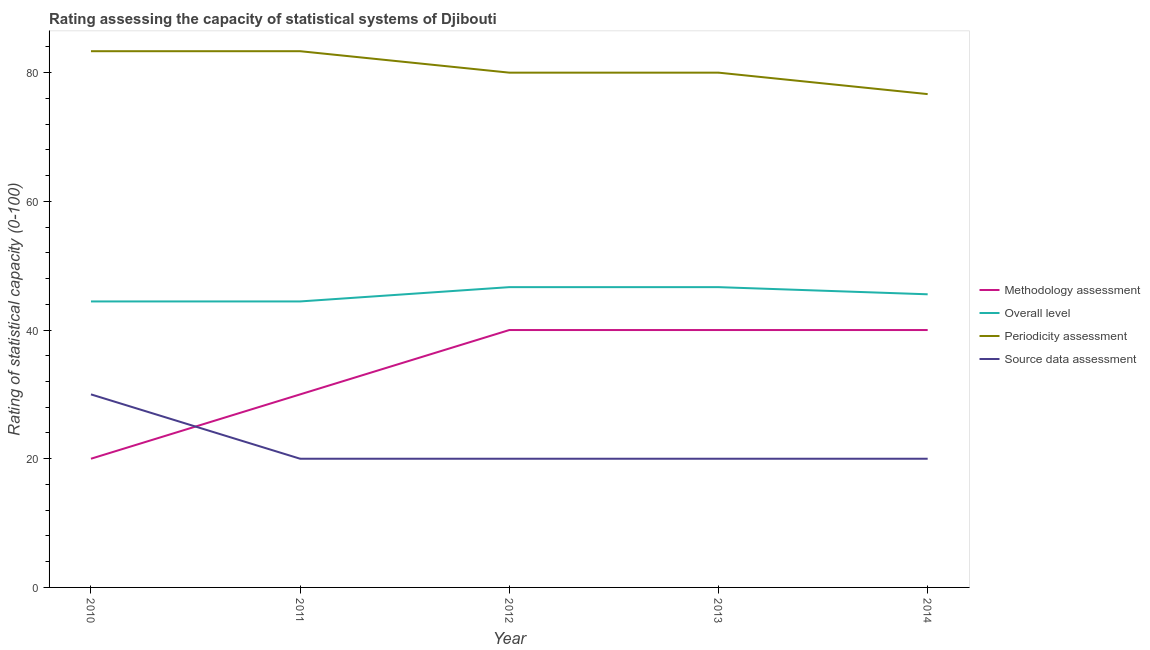How many different coloured lines are there?
Your answer should be very brief. 4. Does the line corresponding to periodicity assessment rating intersect with the line corresponding to overall level rating?
Provide a short and direct response. No. Is the number of lines equal to the number of legend labels?
Offer a very short reply. Yes. What is the periodicity assessment rating in 2011?
Offer a terse response. 83.33. Across all years, what is the maximum source data assessment rating?
Your answer should be very brief. 30. Across all years, what is the minimum periodicity assessment rating?
Offer a very short reply. 76.67. In which year was the periodicity assessment rating maximum?
Ensure brevity in your answer.  2010. In which year was the source data assessment rating minimum?
Give a very brief answer. 2011. What is the total overall level rating in the graph?
Your answer should be very brief. 227.78. What is the difference between the overall level rating in 2010 and that in 2013?
Make the answer very short. -2.22. What is the difference between the overall level rating in 2012 and the methodology assessment rating in 2010?
Provide a succinct answer. 26.67. What is the average periodicity assessment rating per year?
Ensure brevity in your answer.  80.67. In the year 2010, what is the difference between the periodicity assessment rating and methodology assessment rating?
Keep it short and to the point. 63.33. In how many years, is the source data assessment rating greater than 36?
Provide a succinct answer. 0. What is the ratio of the source data assessment rating in 2013 to that in 2014?
Keep it short and to the point. 1. Is the source data assessment rating in 2010 less than that in 2012?
Your response must be concise. No. Is the difference between the periodicity assessment rating in 2011 and 2012 greater than the difference between the overall level rating in 2011 and 2012?
Your answer should be very brief. Yes. What is the difference between the highest and the lowest periodicity assessment rating?
Provide a short and direct response. 6.67. Is the sum of the methodology assessment rating in 2010 and 2012 greater than the maximum overall level rating across all years?
Offer a terse response. Yes. Is the periodicity assessment rating strictly greater than the overall level rating over the years?
Make the answer very short. Yes. How many lines are there?
Offer a terse response. 4. How many years are there in the graph?
Offer a very short reply. 5. What is the difference between two consecutive major ticks on the Y-axis?
Keep it short and to the point. 20. Does the graph contain any zero values?
Give a very brief answer. No. Does the graph contain grids?
Your answer should be very brief. No. Where does the legend appear in the graph?
Offer a very short reply. Center right. How many legend labels are there?
Keep it short and to the point. 4. How are the legend labels stacked?
Keep it short and to the point. Vertical. What is the title of the graph?
Your response must be concise. Rating assessing the capacity of statistical systems of Djibouti. Does "Pre-primary schools" appear as one of the legend labels in the graph?
Your answer should be very brief. No. What is the label or title of the Y-axis?
Offer a terse response. Rating of statistical capacity (0-100). What is the Rating of statistical capacity (0-100) of Overall level in 2010?
Give a very brief answer. 44.44. What is the Rating of statistical capacity (0-100) in Periodicity assessment in 2010?
Offer a terse response. 83.33. What is the Rating of statistical capacity (0-100) of Methodology assessment in 2011?
Keep it short and to the point. 30. What is the Rating of statistical capacity (0-100) in Overall level in 2011?
Provide a short and direct response. 44.44. What is the Rating of statistical capacity (0-100) in Periodicity assessment in 2011?
Ensure brevity in your answer.  83.33. What is the Rating of statistical capacity (0-100) in Source data assessment in 2011?
Ensure brevity in your answer.  20. What is the Rating of statistical capacity (0-100) in Overall level in 2012?
Make the answer very short. 46.67. What is the Rating of statistical capacity (0-100) of Periodicity assessment in 2012?
Ensure brevity in your answer.  80. What is the Rating of statistical capacity (0-100) of Source data assessment in 2012?
Provide a short and direct response. 20. What is the Rating of statistical capacity (0-100) in Methodology assessment in 2013?
Your response must be concise. 40. What is the Rating of statistical capacity (0-100) in Overall level in 2013?
Make the answer very short. 46.67. What is the Rating of statistical capacity (0-100) in Periodicity assessment in 2013?
Your response must be concise. 80. What is the Rating of statistical capacity (0-100) in Methodology assessment in 2014?
Your answer should be compact. 40. What is the Rating of statistical capacity (0-100) in Overall level in 2014?
Give a very brief answer. 45.56. What is the Rating of statistical capacity (0-100) in Periodicity assessment in 2014?
Your answer should be very brief. 76.67. What is the Rating of statistical capacity (0-100) in Source data assessment in 2014?
Ensure brevity in your answer.  20. Across all years, what is the maximum Rating of statistical capacity (0-100) in Overall level?
Your response must be concise. 46.67. Across all years, what is the maximum Rating of statistical capacity (0-100) of Periodicity assessment?
Offer a terse response. 83.33. Across all years, what is the maximum Rating of statistical capacity (0-100) of Source data assessment?
Provide a short and direct response. 30. Across all years, what is the minimum Rating of statistical capacity (0-100) in Methodology assessment?
Give a very brief answer. 20. Across all years, what is the minimum Rating of statistical capacity (0-100) in Overall level?
Your answer should be compact. 44.44. Across all years, what is the minimum Rating of statistical capacity (0-100) of Periodicity assessment?
Offer a very short reply. 76.67. Across all years, what is the minimum Rating of statistical capacity (0-100) of Source data assessment?
Make the answer very short. 20. What is the total Rating of statistical capacity (0-100) in Methodology assessment in the graph?
Ensure brevity in your answer.  170. What is the total Rating of statistical capacity (0-100) in Overall level in the graph?
Give a very brief answer. 227.78. What is the total Rating of statistical capacity (0-100) of Periodicity assessment in the graph?
Offer a terse response. 403.33. What is the total Rating of statistical capacity (0-100) of Source data assessment in the graph?
Provide a short and direct response. 110. What is the difference between the Rating of statistical capacity (0-100) in Methodology assessment in 2010 and that in 2011?
Ensure brevity in your answer.  -10. What is the difference between the Rating of statistical capacity (0-100) of Overall level in 2010 and that in 2011?
Provide a short and direct response. 0. What is the difference between the Rating of statistical capacity (0-100) of Periodicity assessment in 2010 and that in 2011?
Ensure brevity in your answer.  0. What is the difference between the Rating of statistical capacity (0-100) in Source data assessment in 2010 and that in 2011?
Provide a short and direct response. 10. What is the difference between the Rating of statistical capacity (0-100) of Methodology assessment in 2010 and that in 2012?
Provide a short and direct response. -20. What is the difference between the Rating of statistical capacity (0-100) in Overall level in 2010 and that in 2012?
Provide a short and direct response. -2.22. What is the difference between the Rating of statistical capacity (0-100) in Periodicity assessment in 2010 and that in 2012?
Make the answer very short. 3.33. What is the difference between the Rating of statistical capacity (0-100) of Methodology assessment in 2010 and that in 2013?
Make the answer very short. -20. What is the difference between the Rating of statistical capacity (0-100) of Overall level in 2010 and that in 2013?
Your response must be concise. -2.22. What is the difference between the Rating of statistical capacity (0-100) of Periodicity assessment in 2010 and that in 2013?
Make the answer very short. 3.33. What is the difference between the Rating of statistical capacity (0-100) of Methodology assessment in 2010 and that in 2014?
Provide a succinct answer. -20. What is the difference between the Rating of statistical capacity (0-100) in Overall level in 2010 and that in 2014?
Ensure brevity in your answer.  -1.11. What is the difference between the Rating of statistical capacity (0-100) in Source data assessment in 2010 and that in 2014?
Keep it short and to the point. 10. What is the difference between the Rating of statistical capacity (0-100) of Methodology assessment in 2011 and that in 2012?
Your answer should be compact. -10. What is the difference between the Rating of statistical capacity (0-100) of Overall level in 2011 and that in 2012?
Provide a succinct answer. -2.22. What is the difference between the Rating of statistical capacity (0-100) of Source data assessment in 2011 and that in 2012?
Offer a very short reply. 0. What is the difference between the Rating of statistical capacity (0-100) in Methodology assessment in 2011 and that in 2013?
Ensure brevity in your answer.  -10. What is the difference between the Rating of statistical capacity (0-100) in Overall level in 2011 and that in 2013?
Provide a short and direct response. -2.22. What is the difference between the Rating of statistical capacity (0-100) of Methodology assessment in 2011 and that in 2014?
Keep it short and to the point. -10. What is the difference between the Rating of statistical capacity (0-100) in Overall level in 2011 and that in 2014?
Offer a very short reply. -1.11. What is the difference between the Rating of statistical capacity (0-100) of Periodicity assessment in 2011 and that in 2014?
Your answer should be very brief. 6.67. What is the difference between the Rating of statistical capacity (0-100) in Source data assessment in 2011 and that in 2014?
Your response must be concise. 0. What is the difference between the Rating of statistical capacity (0-100) of Methodology assessment in 2012 and that in 2013?
Your answer should be compact. 0. What is the difference between the Rating of statistical capacity (0-100) in Overall level in 2012 and that in 2013?
Provide a succinct answer. 0. What is the difference between the Rating of statistical capacity (0-100) of Overall level in 2012 and that in 2014?
Ensure brevity in your answer.  1.11. What is the difference between the Rating of statistical capacity (0-100) in Periodicity assessment in 2012 and that in 2014?
Your answer should be compact. 3.33. What is the difference between the Rating of statistical capacity (0-100) in Source data assessment in 2012 and that in 2014?
Your response must be concise. 0. What is the difference between the Rating of statistical capacity (0-100) in Methodology assessment in 2013 and that in 2014?
Offer a very short reply. 0. What is the difference between the Rating of statistical capacity (0-100) in Overall level in 2013 and that in 2014?
Offer a terse response. 1.11. What is the difference between the Rating of statistical capacity (0-100) of Source data assessment in 2013 and that in 2014?
Your answer should be very brief. 0. What is the difference between the Rating of statistical capacity (0-100) in Methodology assessment in 2010 and the Rating of statistical capacity (0-100) in Overall level in 2011?
Your answer should be compact. -24.44. What is the difference between the Rating of statistical capacity (0-100) in Methodology assessment in 2010 and the Rating of statistical capacity (0-100) in Periodicity assessment in 2011?
Your answer should be very brief. -63.33. What is the difference between the Rating of statistical capacity (0-100) of Overall level in 2010 and the Rating of statistical capacity (0-100) of Periodicity assessment in 2011?
Provide a succinct answer. -38.89. What is the difference between the Rating of statistical capacity (0-100) in Overall level in 2010 and the Rating of statistical capacity (0-100) in Source data assessment in 2011?
Offer a very short reply. 24.44. What is the difference between the Rating of statistical capacity (0-100) in Periodicity assessment in 2010 and the Rating of statistical capacity (0-100) in Source data assessment in 2011?
Ensure brevity in your answer.  63.33. What is the difference between the Rating of statistical capacity (0-100) in Methodology assessment in 2010 and the Rating of statistical capacity (0-100) in Overall level in 2012?
Keep it short and to the point. -26.67. What is the difference between the Rating of statistical capacity (0-100) of Methodology assessment in 2010 and the Rating of statistical capacity (0-100) of Periodicity assessment in 2012?
Your answer should be compact. -60. What is the difference between the Rating of statistical capacity (0-100) in Methodology assessment in 2010 and the Rating of statistical capacity (0-100) in Source data assessment in 2012?
Your answer should be compact. 0. What is the difference between the Rating of statistical capacity (0-100) of Overall level in 2010 and the Rating of statistical capacity (0-100) of Periodicity assessment in 2012?
Offer a terse response. -35.56. What is the difference between the Rating of statistical capacity (0-100) of Overall level in 2010 and the Rating of statistical capacity (0-100) of Source data assessment in 2012?
Offer a terse response. 24.44. What is the difference between the Rating of statistical capacity (0-100) of Periodicity assessment in 2010 and the Rating of statistical capacity (0-100) of Source data assessment in 2012?
Provide a succinct answer. 63.33. What is the difference between the Rating of statistical capacity (0-100) of Methodology assessment in 2010 and the Rating of statistical capacity (0-100) of Overall level in 2013?
Provide a short and direct response. -26.67. What is the difference between the Rating of statistical capacity (0-100) of Methodology assessment in 2010 and the Rating of statistical capacity (0-100) of Periodicity assessment in 2013?
Offer a terse response. -60. What is the difference between the Rating of statistical capacity (0-100) of Overall level in 2010 and the Rating of statistical capacity (0-100) of Periodicity assessment in 2013?
Provide a short and direct response. -35.56. What is the difference between the Rating of statistical capacity (0-100) of Overall level in 2010 and the Rating of statistical capacity (0-100) of Source data assessment in 2013?
Keep it short and to the point. 24.44. What is the difference between the Rating of statistical capacity (0-100) in Periodicity assessment in 2010 and the Rating of statistical capacity (0-100) in Source data assessment in 2013?
Make the answer very short. 63.33. What is the difference between the Rating of statistical capacity (0-100) in Methodology assessment in 2010 and the Rating of statistical capacity (0-100) in Overall level in 2014?
Give a very brief answer. -25.56. What is the difference between the Rating of statistical capacity (0-100) in Methodology assessment in 2010 and the Rating of statistical capacity (0-100) in Periodicity assessment in 2014?
Give a very brief answer. -56.67. What is the difference between the Rating of statistical capacity (0-100) in Methodology assessment in 2010 and the Rating of statistical capacity (0-100) in Source data assessment in 2014?
Provide a short and direct response. 0. What is the difference between the Rating of statistical capacity (0-100) in Overall level in 2010 and the Rating of statistical capacity (0-100) in Periodicity assessment in 2014?
Give a very brief answer. -32.22. What is the difference between the Rating of statistical capacity (0-100) in Overall level in 2010 and the Rating of statistical capacity (0-100) in Source data assessment in 2014?
Provide a short and direct response. 24.44. What is the difference between the Rating of statistical capacity (0-100) in Periodicity assessment in 2010 and the Rating of statistical capacity (0-100) in Source data assessment in 2014?
Ensure brevity in your answer.  63.33. What is the difference between the Rating of statistical capacity (0-100) of Methodology assessment in 2011 and the Rating of statistical capacity (0-100) of Overall level in 2012?
Give a very brief answer. -16.67. What is the difference between the Rating of statistical capacity (0-100) of Methodology assessment in 2011 and the Rating of statistical capacity (0-100) of Periodicity assessment in 2012?
Make the answer very short. -50. What is the difference between the Rating of statistical capacity (0-100) in Methodology assessment in 2011 and the Rating of statistical capacity (0-100) in Source data assessment in 2012?
Your answer should be very brief. 10. What is the difference between the Rating of statistical capacity (0-100) of Overall level in 2011 and the Rating of statistical capacity (0-100) of Periodicity assessment in 2012?
Give a very brief answer. -35.56. What is the difference between the Rating of statistical capacity (0-100) in Overall level in 2011 and the Rating of statistical capacity (0-100) in Source data assessment in 2012?
Offer a terse response. 24.44. What is the difference between the Rating of statistical capacity (0-100) of Periodicity assessment in 2011 and the Rating of statistical capacity (0-100) of Source data assessment in 2012?
Offer a very short reply. 63.33. What is the difference between the Rating of statistical capacity (0-100) in Methodology assessment in 2011 and the Rating of statistical capacity (0-100) in Overall level in 2013?
Keep it short and to the point. -16.67. What is the difference between the Rating of statistical capacity (0-100) of Methodology assessment in 2011 and the Rating of statistical capacity (0-100) of Source data assessment in 2013?
Keep it short and to the point. 10. What is the difference between the Rating of statistical capacity (0-100) of Overall level in 2011 and the Rating of statistical capacity (0-100) of Periodicity assessment in 2013?
Ensure brevity in your answer.  -35.56. What is the difference between the Rating of statistical capacity (0-100) in Overall level in 2011 and the Rating of statistical capacity (0-100) in Source data assessment in 2013?
Give a very brief answer. 24.44. What is the difference between the Rating of statistical capacity (0-100) of Periodicity assessment in 2011 and the Rating of statistical capacity (0-100) of Source data assessment in 2013?
Provide a succinct answer. 63.33. What is the difference between the Rating of statistical capacity (0-100) of Methodology assessment in 2011 and the Rating of statistical capacity (0-100) of Overall level in 2014?
Your response must be concise. -15.56. What is the difference between the Rating of statistical capacity (0-100) of Methodology assessment in 2011 and the Rating of statistical capacity (0-100) of Periodicity assessment in 2014?
Give a very brief answer. -46.67. What is the difference between the Rating of statistical capacity (0-100) in Overall level in 2011 and the Rating of statistical capacity (0-100) in Periodicity assessment in 2014?
Offer a very short reply. -32.22. What is the difference between the Rating of statistical capacity (0-100) in Overall level in 2011 and the Rating of statistical capacity (0-100) in Source data assessment in 2014?
Your response must be concise. 24.44. What is the difference between the Rating of statistical capacity (0-100) in Periodicity assessment in 2011 and the Rating of statistical capacity (0-100) in Source data assessment in 2014?
Offer a terse response. 63.33. What is the difference between the Rating of statistical capacity (0-100) of Methodology assessment in 2012 and the Rating of statistical capacity (0-100) of Overall level in 2013?
Your answer should be very brief. -6.67. What is the difference between the Rating of statistical capacity (0-100) in Methodology assessment in 2012 and the Rating of statistical capacity (0-100) in Periodicity assessment in 2013?
Your answer should be compact. -40. What is the difference between the Rating of statistical capacity (0-100) of Methodology assessment in 2012 and the Rating of statistical capacity (0-100) of Source data assessment in 2013?
Keep it short and to the point. 20. What is the difference between the Rating of statistical capacity (0-100) of Overall level in 2012 and the Rating of statistical capacity (0-100) of Periodicity assessment in 2013?
Offer a very short reply. -33.33. What is the difference between the Rating of statistical capacity (0-100) of Overall level in 2012 and the Rating of statistical capacity (0-100) of Source data assessment in 2013?
Ensure brevity in your answer.  26.67. What is the difference between the Rating of statistical capacity (0-100) of Methodology assessment in 2012 and the Rating of statistical capacity (0-100) of Overall level in 2014?
Make the answer very short. -5.56. What is the difference between the Rating of statistical capacity (0-100) in Methodology assessment in 2012 and the Rating of statistical capacity (0-100) in Periodicity assessment in 2014?
Your answer should be compact. -36.67. What is the difference between the Rating of statistical capacity (0-100) of Methodology assessment in 2012 and the Rating of statistical capacity (0-100) of Source data assessment in 2014?
Your response must be concise. 20. What is the difference between the Rating of statistical capacity (0-100) of Overall level in 2012 and the Rating of statistical capacity (0-100) of Periodicity assessment in 2014?
Give a very brief answer. -30. What is the difference between the Rating of statistical capacity (0-100) in Overall level in 2012 and the Rating of statistical capacity (0-100) in Source data assessment in 2014?
Your response must be concise. 26.67. What is the difference between the Rating of statistical capacity (0-100) in Periodicity assessment in 2012 and the Rating of statistical capacity (0-100) in Source data assessment in 2014?
Make the answer very short. 60. What is the difference between the Rating of statistical capacity (0-100) in Methodology assessment in 2013 and the Rating of statistical capacity (0-100) in Overall level in 2014?
Offer a very short reply. -5.56. What is the difference between the Rating of statistical capacity (0-100) in Methodology assessment in 2013 and the Rating of statistical capacity (0-100) in Periodicity assessment in 2014?
Your answer should be compact. -36.67. What is the difference between the Rating of statistical capacity (0-100) in Methodology assessment in 2013 and the Rating of statistical capacity (0-100) in Source data assessment in 2014?
Provide a succinct answer. 20. What is the difference between the Rating of statistical capacity (0-100) in Overall level in 2013 and the Rating of statistical capacity (0-100) in Periodicity assessment in 2014?
Keep it short and to the point. -30. What is the difference between the Rating of statistical capacity (0-100) in Overall level in 2013 and the Rating of statistical capacity (0-100) in Source data assessment in 2014?
Your answer should be compact. 26.67. What is the difference between the Rating of statistical capacity (0-100) in Periodicity assessment in 2013 and the Rating of statistical capacity (0-100) in Source data assessment in 2014?
Make the answer very short. 60. What is the average Rating of statistical capacity (0-100) of Overall level per year?
Offer a terse response. 45.56. What is the average Rating of statistical capacity (0-100) in Periodicity assessment per year?
Ensure brevity in your answer.  80.67. What is the average Rating of statistical capacity (0-100) of Source data assessment per year?
Ensure brevity in your answer.  22. In the year 2010, what is the difference between the Rating of statistical capacity (0-100) of Methodology assessment and Rating of statistical capacity (0-100) of Overall level?
Your answer should be compact. -24.44. In the year 2010, what is the difference between the Rating of statistical capacity (0-100) of Methodology assessment and Rating of statistical capacity (0-100) of Periodicity assessment?
Make the answer very short. -63.33. In the year 2010, what is the difference between the Rating of statistical capacity (0-100) in Overall level and Rating of statistical capacity (0-100) in Periodicity assessment?
Offer a terse response. -38.89. In the year 2010, what is the difference between the Rating of statistical capacity (0-100) of Overall level and Rating of statistical capacity (0-100) of Source data assessment?
Ensure brevity in your answer.  14.44. In the year 2010, what is the difference between the Rating of statistical capacity (0-100) in Periodicity assessment and Rating of statistical capacity (0-100) in Source data assessment?
Make the answer very short. 53.33. In the year 2011, what is the difference between the Rating of statistical capacity (0-100) in Methodology assessment and Rating of statistical capacity (0-100) in Overall level?
Offer a terse response. -14.44. In the year 2011, what is the difference between the Rating of statistical capacity (0-100) of Methodology assessment and Rating of statistical capacity (0-100) of Periodicity assessment?
Give a very brief answer. -53.33. In the year 2011, what is the difference between the Rating of statistical capacity (0-100) of Overall level and Rating of statistical capacity (0-100) of Periodicity assessment?
Offer a very short reply. -38.89. In the year 2011, what is the difference between the Rating of statistical capacity (0-100) in Overall level and Rating of statistical capacity (0-100) in Source data assessment?
Make the answer very short. 24.44. In the year 2011, what is the difference between the Rating of statistical capacity (0-100) of Periodicity assessment and Rating of statistical capacity (0-100) of Source data assessment?
Keep it short and to the point. 63.33. In the year 2012, what is the difference between the Rating of statistical capacity (0-100) in Methodology assessment and Rating of statistical capacity (0-100) in Overall level?
Keep it short and to the point. -6.67. In the year 2012, what is the difference between the Rating of statistical capacity (0-100) of Methodology assessment and Rating of statistical capacity (0-100) of Source data assessment?
Make the answer very short. 20. In the year 2012, what is the difference between the Rating of statistical capacity (0-100) of Overall level and Rating of statistical capacity (0-100) of Periodicity assessment?
Provide a short and direct response. -33.33. In the year 2012, what is the difference between the Rating of statistical capacity (0-100) in Overall level and Rating of statistical capacity (0-100) in Source data assessment?
Your answer should be compact. 26.67. In the year 2012, what is the difference between the Rating of statistical capacity (0-100) of Periodicity assessment and Rating of statistical capacity (0-100) of Source data assessment?
Offer a terse response. 60. In the year 2013, what is the difference between the Rating of statistical capacity (0-100) in Methodology assessment and Rating of statistical capacity (0-100) in Overall level?
Keep it short and to the point. -6.67. In the year 2013, what is the difference between the Rating of statistical capacity (0-100) of Methodology assessment and Rating of statistical capacity (0-100) of Source data assessment?
Provide a short and direct response. 20. In the year 2013, what is the difference between the Rating of statistical capacity (0-100) of Overall level and Rating of statistical capacity (0-100) of Periodicity assessment?
Give a very brief answer. -33.33. In the year 2013, what is the difference between the Rating of statistical capacity (0-100) in Overall level and Rating of statistical capacity (0-100) in Source data assessment?
Provide a short and direct response. 26.67. In the year 2013, what is the difference between the Rating of statistical capacity (0-100) in Periodicity assessment and Rating of statistical capacity (0-100) in Source data assessment?
Offer a terse response. 60. In the year 2014, what is the difference between the Rating of statistical capacity (0-100) in Methodology assessment and Rating of statistical capacity (0-100) in Overall level?
Your answer should be very brief. -5.56. In the year 2014, what is the difference between the Rating of statistical capacity (0-100) of Methodology assessment and Rating of statistical capacity (0-100) of Periodicity assessment?
Provide a short and direct response. -36.67. In the year 2014, what is the difference between the Rating of statistical capacity (0-100) in Overall level and Rating of statistical capacity (0-100) in Periodicity assessment?
Make the answer very short. -31.11. In the year 2014, what is the difference between the Rating of statistical capacity (0-100) in Overall level and Rating of statistical capacity (0-100) in Source data assessment?
Provide a short and direct response. 25.56. In the year 2014, what is the difference between the Rating of statistical capacity (0-100) in Periodicity assessment and Rating of statistical capacity (0-100) in Source data assessment?
Offer a very short reply. 56.67. What is the ratio of the Rating of statistical capacity (0-100) in Methodology assessment in 2010 to that in 2011?
Your answer should be compact. 0.67. What is the ratio of the Rating of statistical capacity (0-100) of Overall level in 2010 to that in 2011?
Offer a terse response. 1. What is the ratio of the Rating of statistical capacity (0-100) of Periodicity assessment in 2010 to that in 2011?
Keep it short and to the point. 1. What is the ratio of the Rating of statistical capacity (0-100) of Source data assessment in 2010 to that in 2011?
Offer a very short reply. 1.5. What is the ratio of the Rating of statistical capacity (0-100) in Methodology assessment in 2010 to that in 2012?
Provide a short and direct response. 0.5. What is the ratio of the Rating of statistical capacity (0-100) of Overall level in 2010 to that in 2012?
Provide a succinct answer. 0.95. What is the ratio of the Rating of statistical capacity (0-100) in Periodicity assessment in 2010 to that in 2012?
Give a very brief answer. 1.04. What is the ratio of the Rating of statistical capacity (0-100) of Methodology assessment in 2010 to that in 2013?
Ensure brevity in your answer.  0.5. What is the ratio of the Rating of statistical capacity (0-100) in Periodicity assessment in 2010 to that in 2013?
Give a very brief answer. 1.04. What is the ratio of the Rating of statistical capacity (0-100) of Source data assessment in 2010 to that in 2013?
Make the answer very short. 1.5. What is the ratio of the Rating of statistical capacity (0-100) of Overall level in 2010 to that in 2014?
Make the answer very short. 0.98. What is the ratio of the Rating of statistical capacity (0-100) in Periodicity assessment in 2010 to that in 2014?
Provide a short and direct response. 1.09. What is the ratio of the Rating of statistical capacity (0-100) in Methodology assessment in 2011 to that in 2012?
Ensure brevity in your answer.  0.75. What is the ratio of the Rating of statistical capacity (0-100) of Periodicity assessment in 2011 to that in 2012?
Provide a short and direct response. 1.04. What is the ratio of the Rating of statistical capacity (0-100) of Source data assessment in 2011 to that in 2012?
Keep it short and to the point. 1. What is the ratio of the Rating of statistical capacity (0-100) in Periodicity assessment in 2011 to that in 2013?
Provide a short and direct response. 1.04. What is the ratio of the Rating of statistical capacity (0-100) of Source data assessment in 2011 to that in 2013?
Offer a very short reply. 1. What is the ratio of the Rating of statistical capacity (0-100) in Overall level in 2011 to that in 2014?
Ensure brevity in your answer.  0.98. What is the ratio of the Rating of statistical capacity (0-100) of Periodicity assessment in 2011 to that in 2014?
Make the answer very short. 1.09. What is the ratio of the Rating of statistical capacity (0-100) in Source data assessment in 2011 to that in 2014?
Ensure brevity in your answer.  1. What is the ratio of the Rating of statistical capacity (0-100) of Methodology assessment in 2012 to that in 2013?
Your answer should be very brief. 1. What is the ratio of the Rating of statistical capacity (0-100) in Periodicity assessment in 2012 to that in 2013?
Offer a very short reply. 1. What is the ratio of the Rating of statistical capacity (0-100) in Methodology assessment in 2012 to that in 2014?
Offer a very short reply. 1. What is the ratio of the Rating of statistical capacity (0-100) of Overall level in 2012 to that in 2014?
Your response must be concise. 1.02. What is the ratio of the Rating of statistical capacity (0-100) of Periodicity assessment in 2012 to that in 2014?
Offer a very short reply. 1.04. What is the ratio of the Rating of statistical capacity (0-100) in Overall level in 2013 to that in 2014?
Ensure brevity in your answer.  1.02. What is the ratio of the Rating of statistical capacity (0-100) in Periodicity assessment in 2013 to that in 2014?
Your answer should be very brief. 1.04. What is the ratio of the Rating of statistical capacity (0-100) of Source data assessment in 2013 to that in 2014?
Keep it short and to the point. 1. What is the difference between the highest and the lowest Rating of statistical capacity (0-100) in Overall level?
Offer a very short reply. 2.22. What is the difference between the highest and the lowest Rating of statistical capacity (0-100) of Source data assessment?
Offer a terse response. 10. 